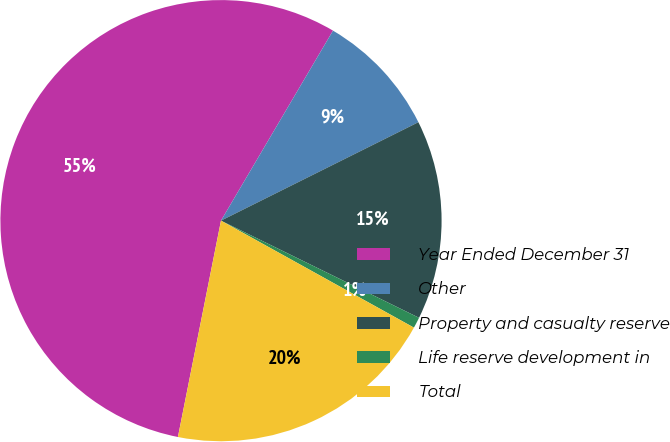<chart> <loc_0><loc_0><loc_500><loc_500><pie_chart><fcel>Year Ended December 31<fcel>Other<fcel>Property and casualty reserve<fcel>Life reserve development in<fcel>Total<nl><fcel>55.35%<fcel>9.16%<fcel>14.62%<fcel>0.8%<fcel>20.07%<nl></chart> 